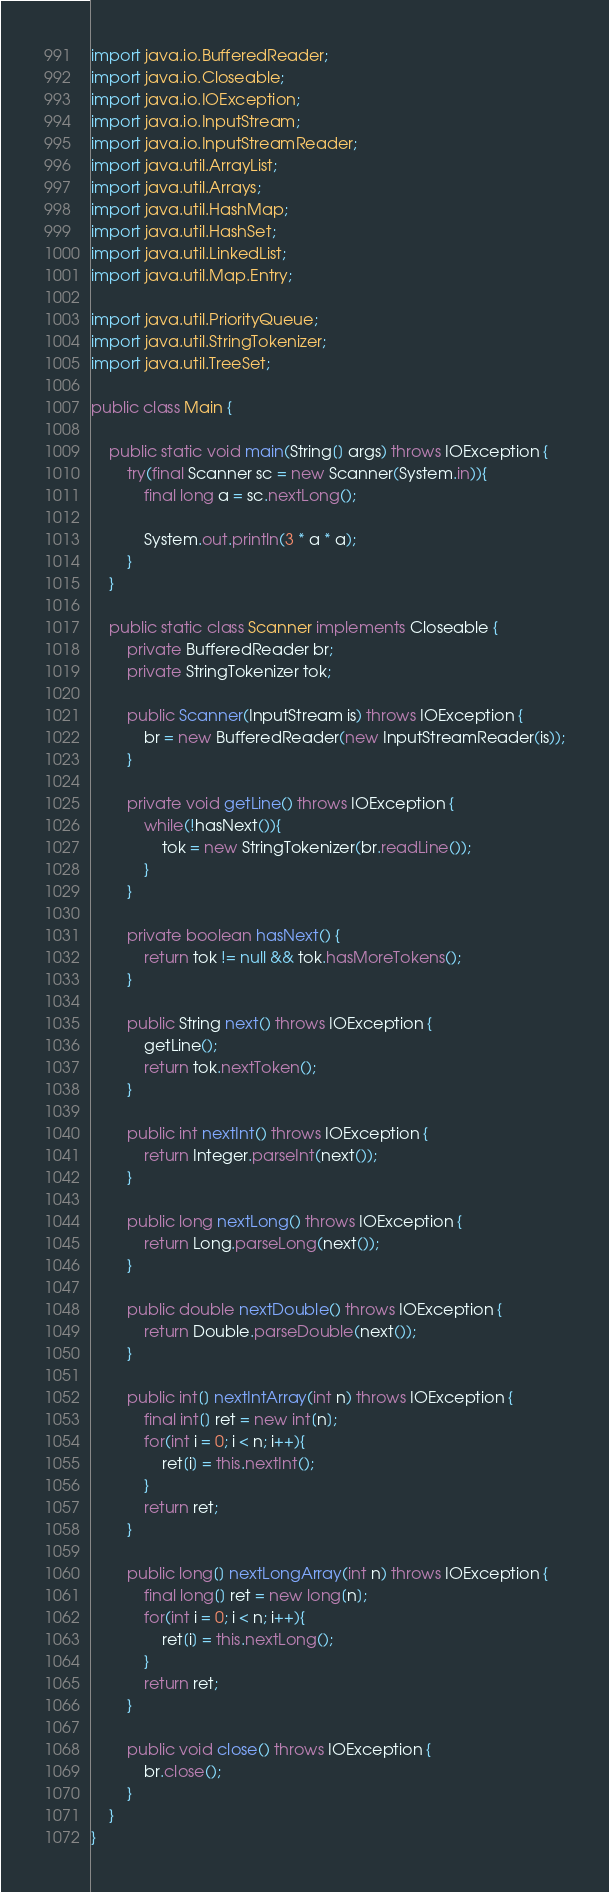Convert code to text. <code><loc_0><loc_0><loc_500><loc_500><_Java_>import java.io.BufferedReader;
import java.io.Closeable;
import java.io.IOException;
import java.io.InputStream;
import java.io.InputStreamReader;
import java.util.ArrayList;
import java.util.Arrays;
import java.util.HashMap;
import java.util.HashSet;
import java.util.LinkedList;
import java.util.Map.Entry;

import java.util.PriorityQueue;
import java.util.StringTokenizer;
import java.util.TreeSet;

public class Main {
	
	public static void main(String[] args) throws IOException {
		try(final Scanner sc = new Scanner(System.in)){
			final long a = sc.nextLong();
			
			System.out.println(3 * a * a);
		}
	}

	public static class Scanner implements Closeable {
		private BufferedReader br;
		private StringTokenizer tok;

		public Scanner(InputStream is) throws IOException {
			br = new BufferedReader(new InputStreamReader(is));
		}

		private void getLine() throws IOException {
			while(!hasNext()){
				tok = new StringTokenizer(br.readLine());
			}
		}

		private boolean hasNext() {
			return tok != null && tok.hasMoreTokens();
		}

		public String next() throws IOException {
			getLine();
			return tok.nextToken();
		}

		public int nextInt() throws IOException {
			return Integer.parseInt(next());
		}

		public long nextLong() throws IOException {
			return Long.parseLong(next());
		}

		public double nextDouble() throws IOException {
			return Double.parseDouble(next());
		}

		public int[] nextIntArray(int n) throws IOException {
			final int[] ret = new int[n];
			for(int i = 0; i < n; i++){
				ret[i] = this.nextInt();
			}
			return ret;
		}

		public long[] nextLongArray(int n) throws IOException {
			final long[] ret = new long[n];
			for(int i = 0; i < n; i++){
				ret[i] = this.nextLong();
			}
			return ret;
		}

		public void close() throws IOException {
			br.close();
		}
	}
}</code> 